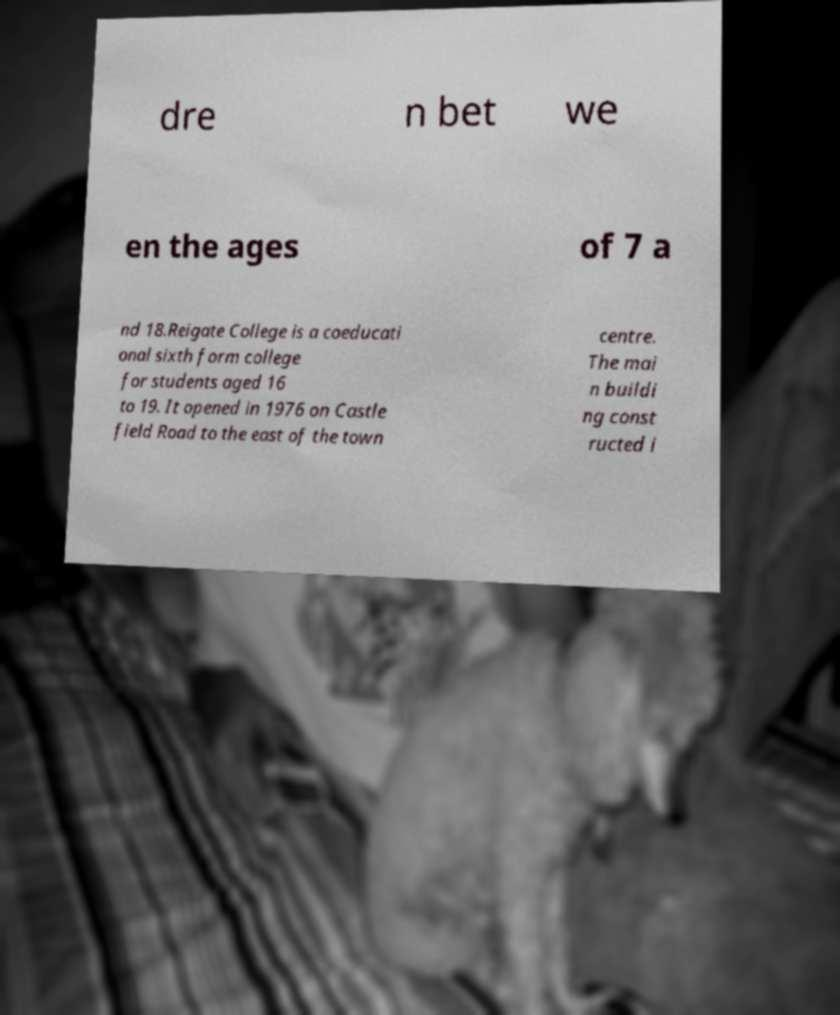There's text embedded in this image that I need extracted. Can you transcribe it verbatim? dre n bet we en the ages of 7 a nd 18.Reigate College is a coeducati onal sixth form college for students aged 16 to 19. It opened in 1976 on Castle field Road to the east of the town centre. The mai n buildi ng const ructed i 